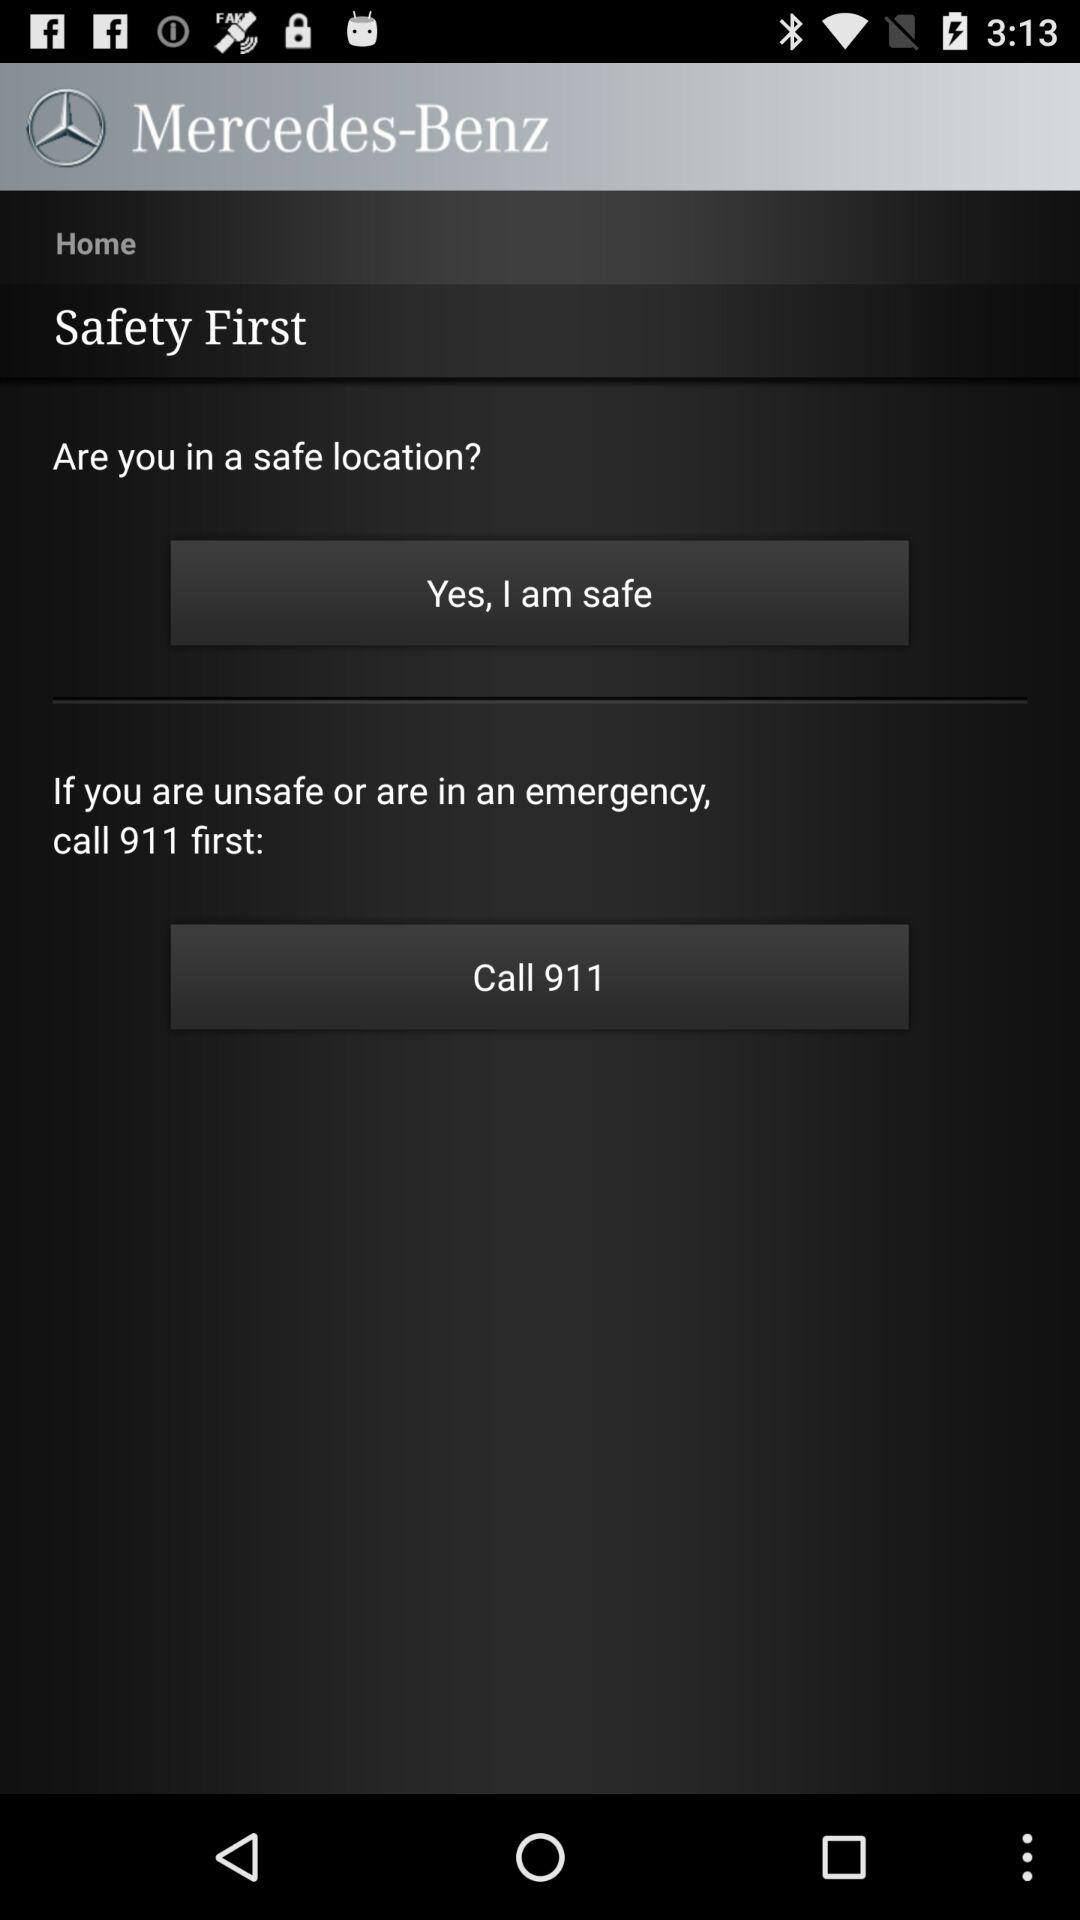What is the application name? The application name is "Mercedes-Benz". 